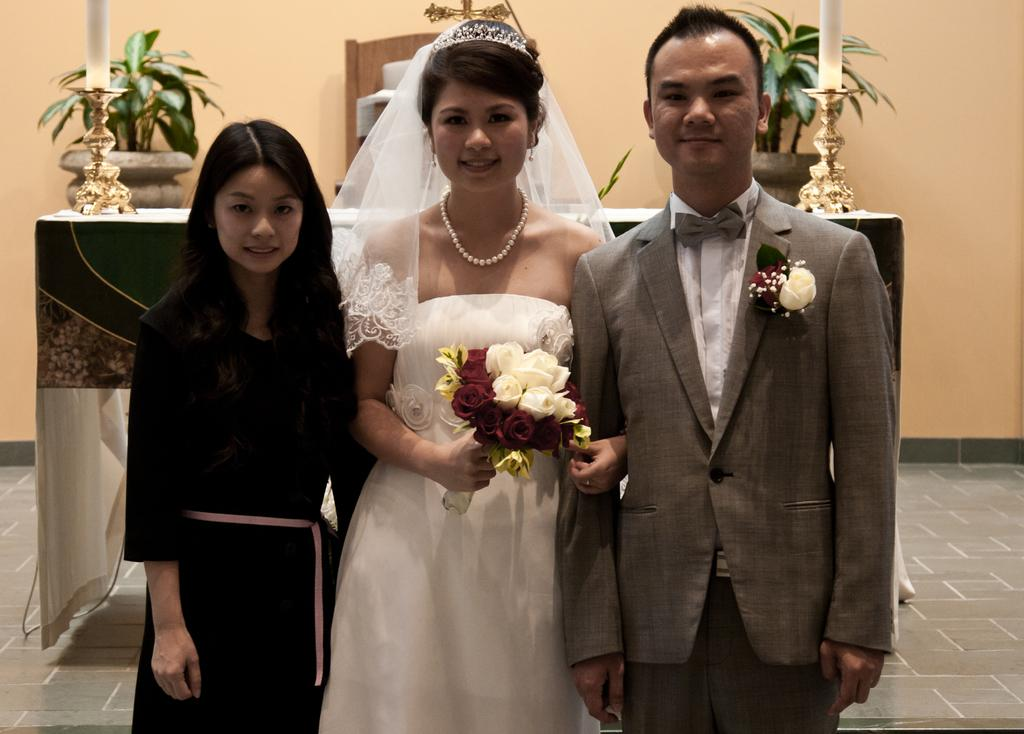How many people are present in the image? There are three people standing in the image. What is the woman holding in the image? The woman is holding flowers in the image. What can be seen in the background of the image? There are plants, candles, and a wall visible in the background of the image. What type of surface is visible beneath the people? There is a floor visible in the image. What type of heart-shaped whip can be seen in the hands of one of the people in the image? There is no heart-shaped whip present in the image. 